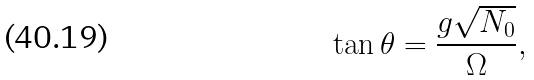Convert formula to latex. <formula><loc_0><loc_0><loc_500><loc_500>\tan \theta = \frac { g \sqrt { N _ { 0 } } } { \Omega } ,</formula> 